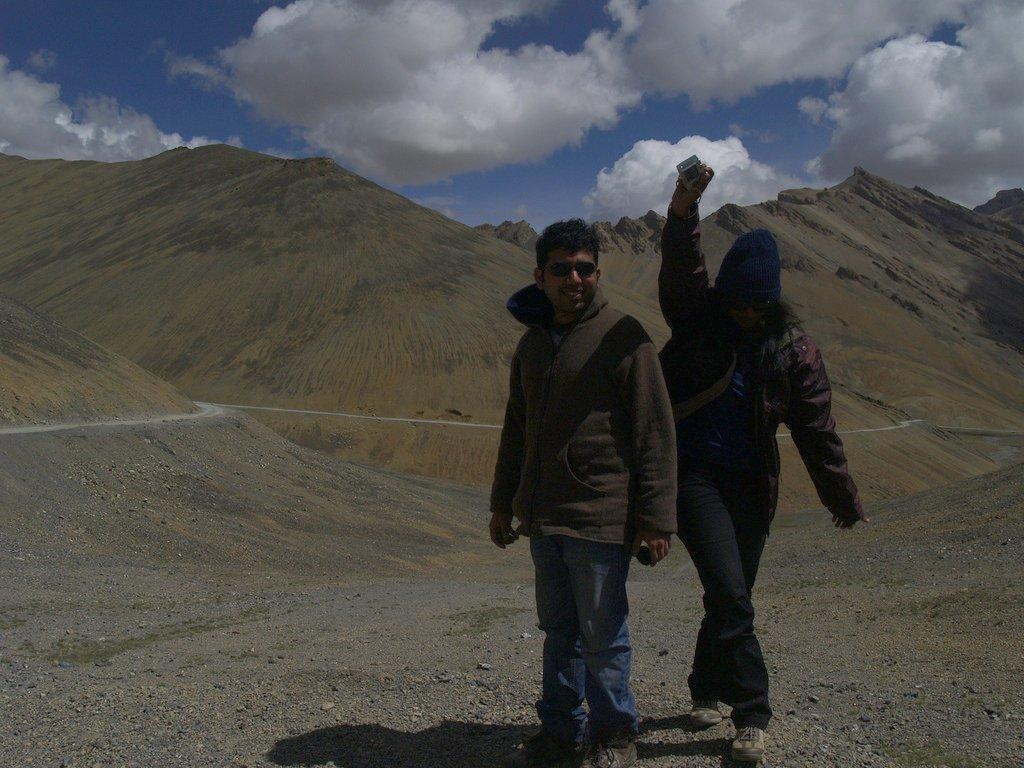How many people are in the image? There are two persons standing on the right side of the image. What can be seen in the background of the image? There are mountains in the background of the image. How would you describe the sky in the image? The sky is cloudy in the image. What color is the lunchroom in the image? There is no lunchroom present in the image. Do the mountains have wings in the image? The mountains do not have wings in the image; they are natural landforms. 